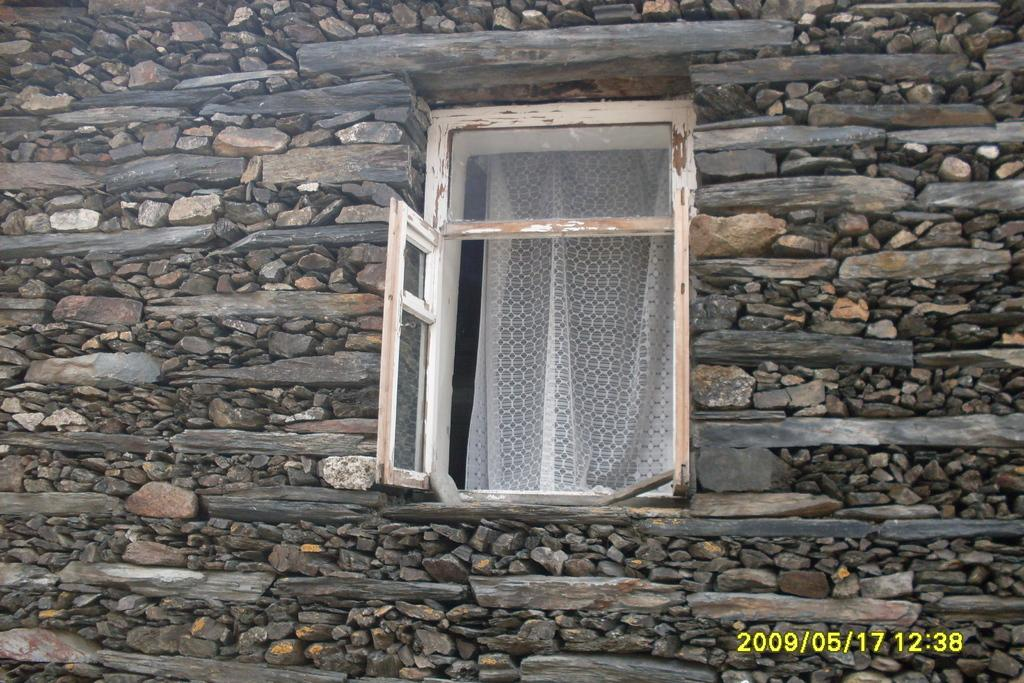What can be seen on the wall in the image? There is a window on the wall in the image. What material is the wall made of? The wall is made up of stones. What type of window treatment is present in the image? There are curtains on the window. What type of ticket can be seen hanging from the window in the image? There is no ticket present in the image; it only features a window with curtains on a stone wall. 